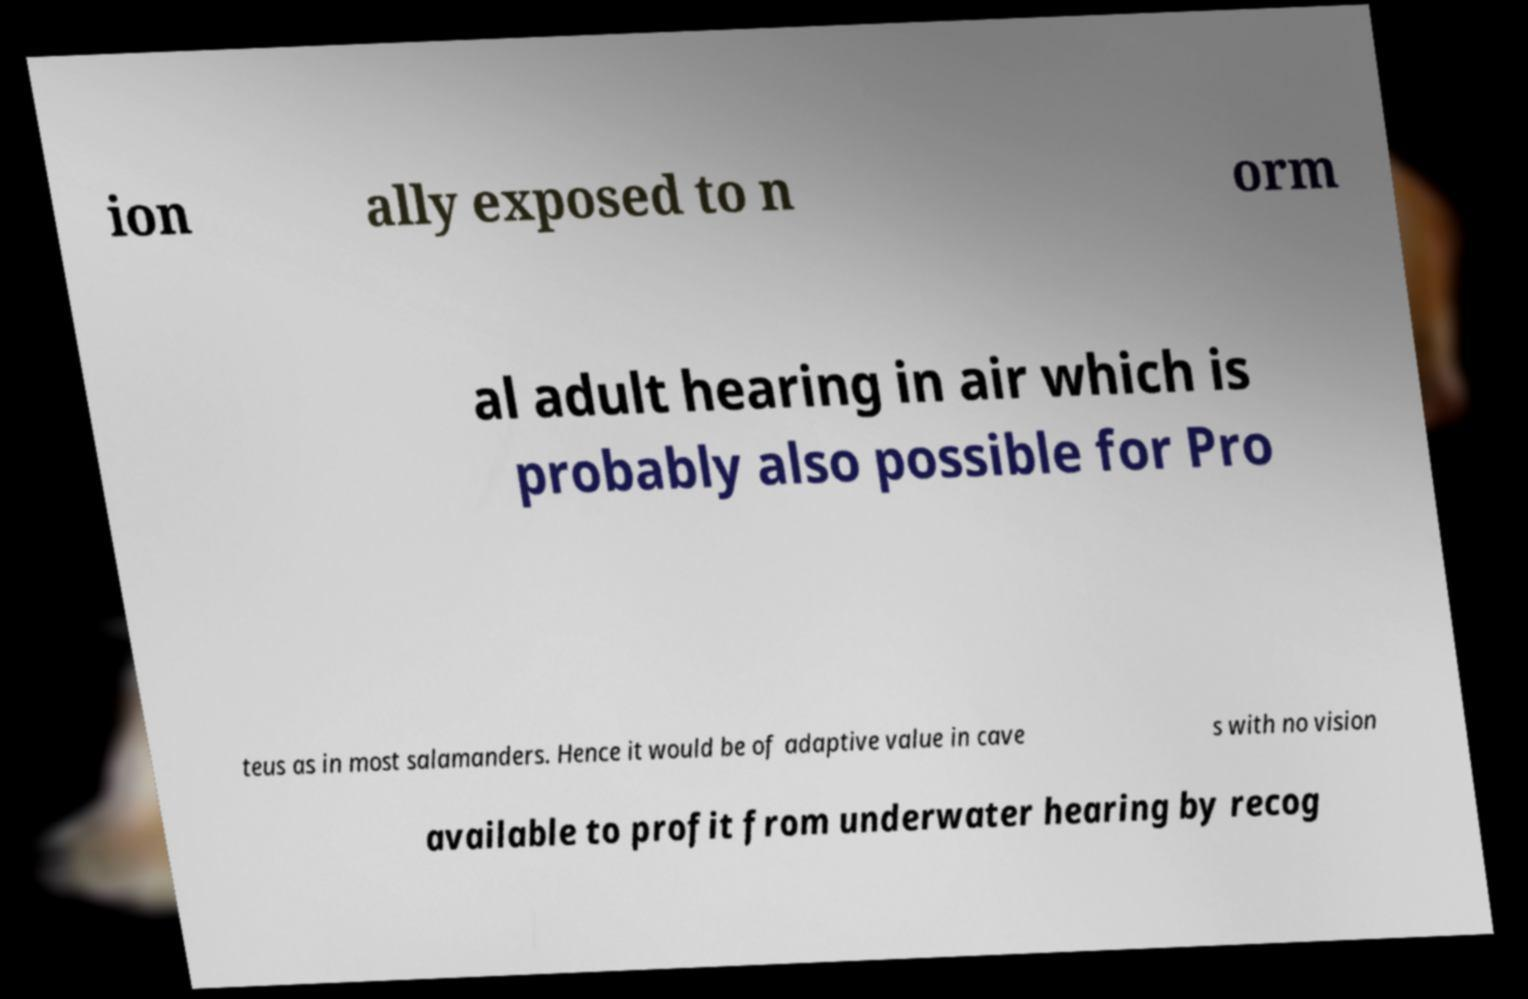Could you assist in decoding the text presented in this image and type it out clearly? ion ally exposed to n orm al adult hearing in air which is probably also possible for Pro teus as in most salamanders. Hence it would be of adaptive value in cave s with no vision available to profit from underwater hearing by recog 